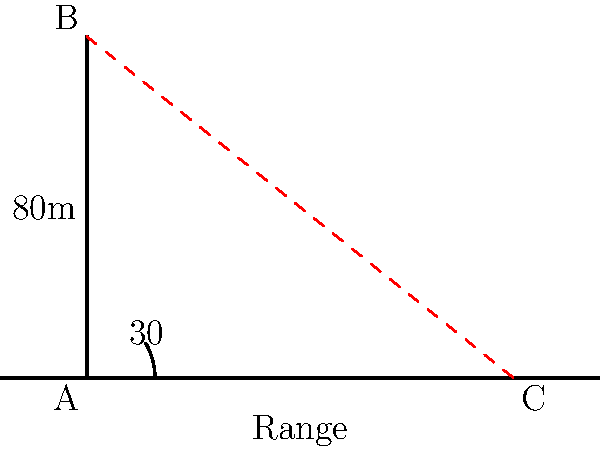A communication tower is being set up in a remote area near a conflict zone to ensure emergency services can maintain contact. The tower is 80 meters tall, and the signal it emits reaches the ground at an angle of 30° from the horizontal at the top of the tower. Calculate the range of the communication tower's signal on flat ground. Round your answer to the nearest meter. Let's approach this step-by-step:

1) We can treat this as a right-angled triangle problem. The tower forms the vertical side (adjacent to the 30° angle), and we need to find the horizontal distance (opposite to the 60° angle at the base).

2) In this triangle:
   - The adjacent side (height of the tower) is 80 meters
   - The angle at the top is 30°
   - We need to find the opposite side (the range)

3) We can use the tangent function to solve this:

   $\tan 30° = \frac{\text{opposite}}{\text{adjacent}} = \frac{\text{range}}{80}$

4) We know that $\tan 30° = \frac{1}{\sqrt{3}}$, so:

   $\frac{1}{\sqrt{3}} = \frac{\text{range}}{80}$

5) Cross multiply:

   $80 = \text{range} \cdot \sqrt{3}$

6) Solve for range:

   $\text{range} = \frac{80}{\sqrt{3}} \approx 46.19$ meters

7) Rounding to the nearest meter:

   $\text{range} \approx 46$ meters
Answer: 46 meters 